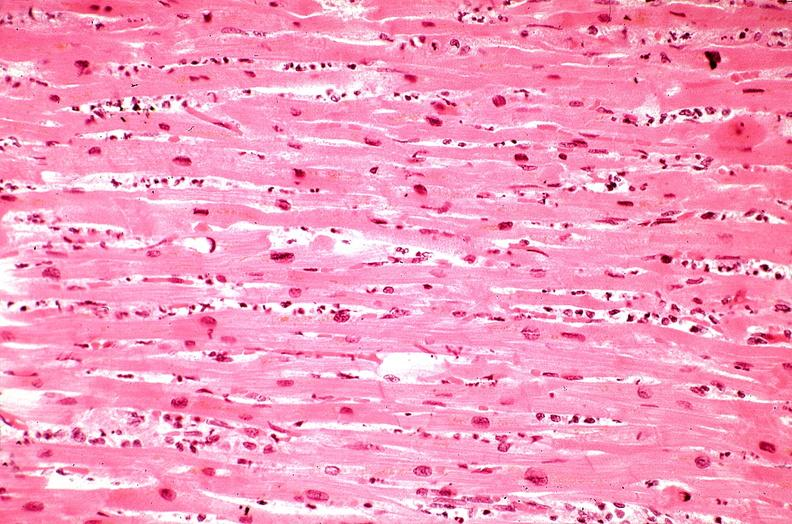s cardiovascular present?
Answer the question using a single word or phrase. Yes 